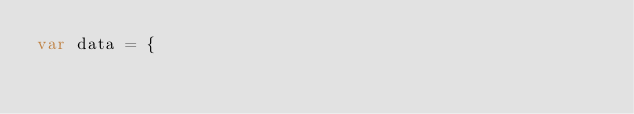Convert code to text. <code><loc_0><loc_0><loc_500><loc_500><_JavaScript_>var data = {</code> 